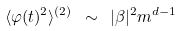Convert formula to latex. <formula><loc_0><loc_0><loc_500><loc_500>\langle \varphi ( t ) ^ { 2 } \rangle ^ { ( 2 ) } \ \sim \ | \beta | ^ { 2 } m ^ { d - 1 }</formula> 